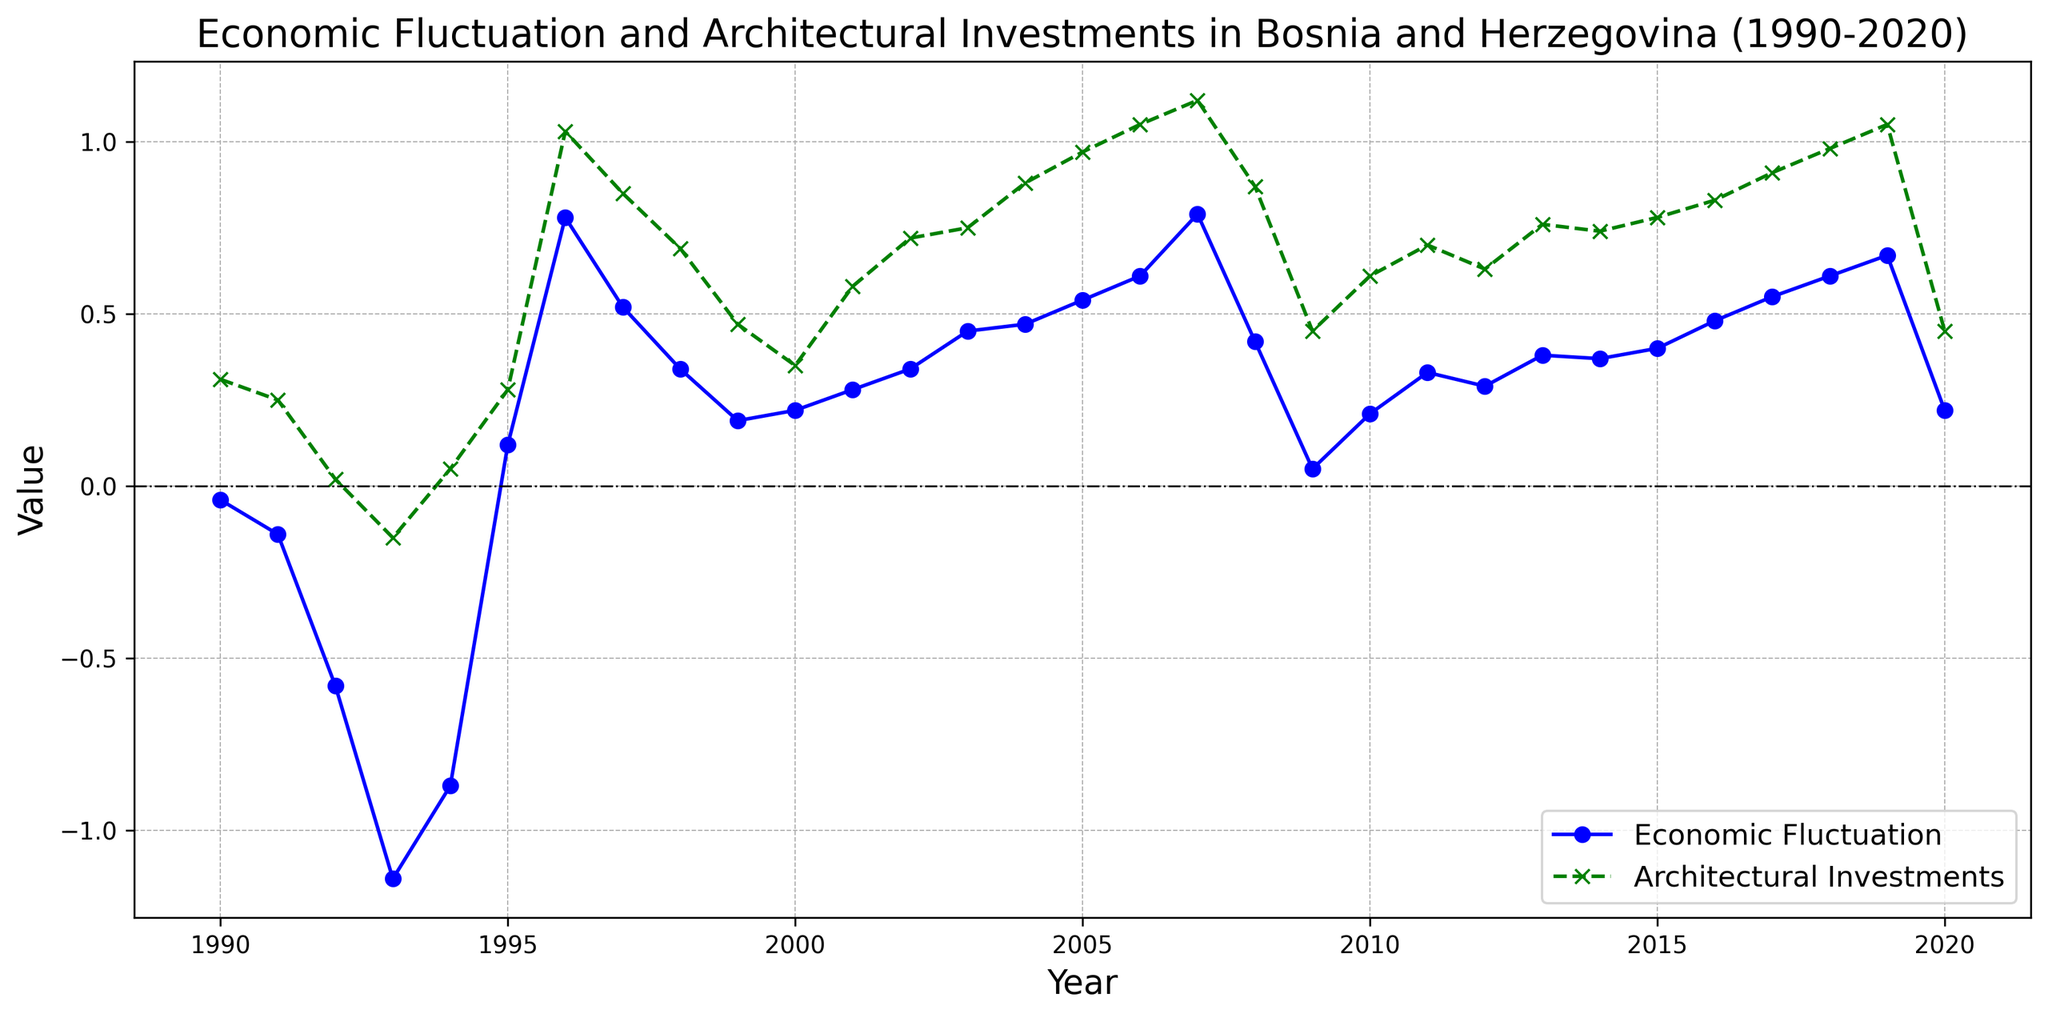What is the economic fluctuation value in 1993? Look at the economic fluctuation line (blue) and find the value for the year 1993. The point lies at -1.14.
Answer: -1.14 Which year had the highest architectural investment value? Observing the architectural investment line (green), the peak value is at 1996 with an investment of 1.03.
Answer: 1996 How do architectural investments compare between 1993 and 1996? In 1993, the investment value was -0.15, whereas in 1996, it was 1.03, indicating a significant increase over these years.
Answer: 1996 is higher What is the total sum of economic fluctuations from 1990 to 1993? Sum up the economic fluctuation values from 1990 to 1993: (-0.04) + (-0.14) + (-0.58) + (-1.14) = -1.90.
Answer: -1.90 Between which years did architectural investments see the greatest increase? Observing the changes, the biggest increase appears between 1995 and 1996, where it goes from 0.28 to 1.03, a jump of 0.75.
Answer: 1995-1996 What was the overall trend in economic fluctuations from 2008 to 2012? From 2008 to 2012, economic fluctuations showed a trend of decline (0.42 in 2008 to 0.29 in 2012), followed by a small increase.
Answer: Decline then small increase Compare the economic fluctuation value in 2009 and 2020? The economic fluctuation was 0.05 in 2009 and 0.22 in 2020, indicating an increase over this period.
Answer: 2020 is higher Calculate the average architectural investment value for the years 2015, 2016, and 2017. Average = (0.78 + 0.83 + 0.91) / 3 = 2.52 / 3 = 0.84.
Answer: 0.84 What was the difference between the highest economic fluctuation and the lowest economic fluctuation year? The highest is 0.79 (2007) and the lowest is -1.14 (1993). Difference is 0.79 - (-1.14) = 1.93.
Answer: 1.93 